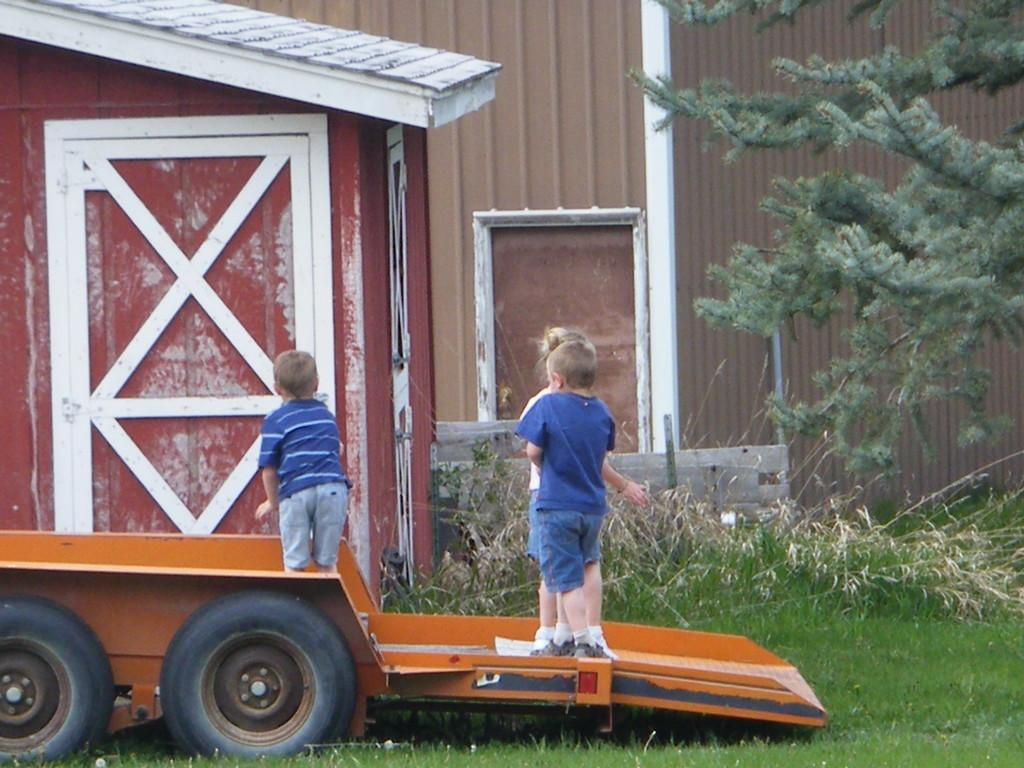What type of surface is visible on the ground in the image? There is grass on the ground in the image. What is located in the center of the image? There is a cart in the center of the image. What are the kids doing in the image? Kids are standing on the cart. What can be seen in the background of the image? There is a tree and a house in the background of the image. How many ladybugs are crawling on the tree in the image? There are no ladybugs visible in the image; only a tree and a house can be seen in the background. What type of dinosaurs are roaming around the kids on the cart? There are no dinosaurs present in the image; only kids are standing on the cart. 